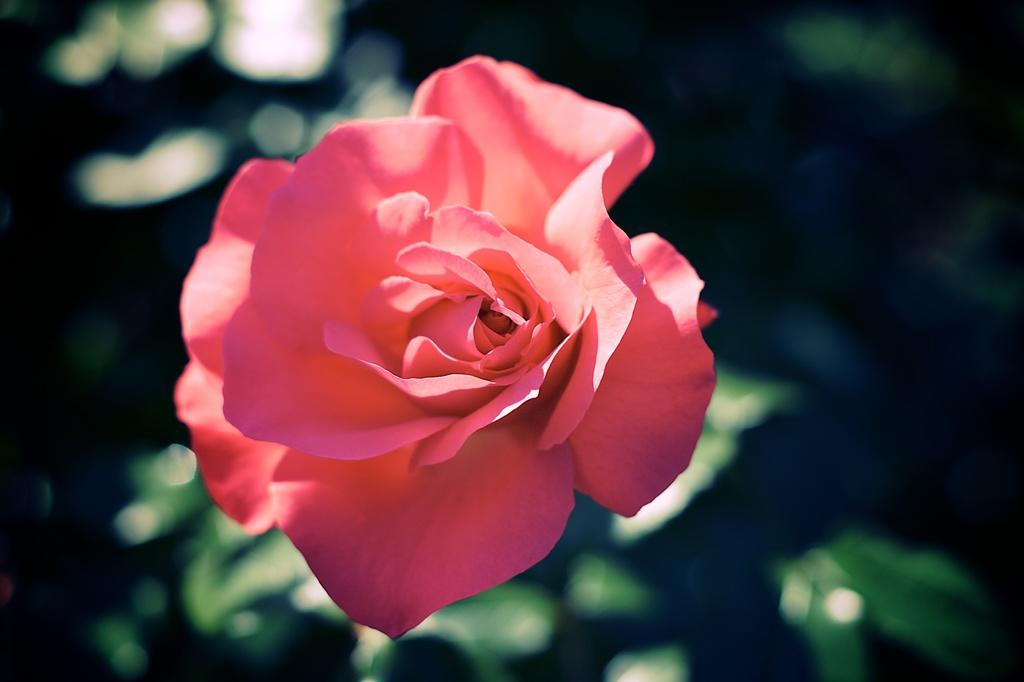What is the color of the rose in the picture? The rose in the picture is pink. What else can be seen in the picture besides the rose? There are leaves in the picture. How is the background of the picture depicted? The rest of the backdrop is blurred. What type of cheese is present in the picture? There is no cheese present in the picture; it features a pink rose and leaves. What kind of jewel can be seen on the rose in the picture? There is no jewel present on the rose in the picture; it is a simple pink rose with leaves. 